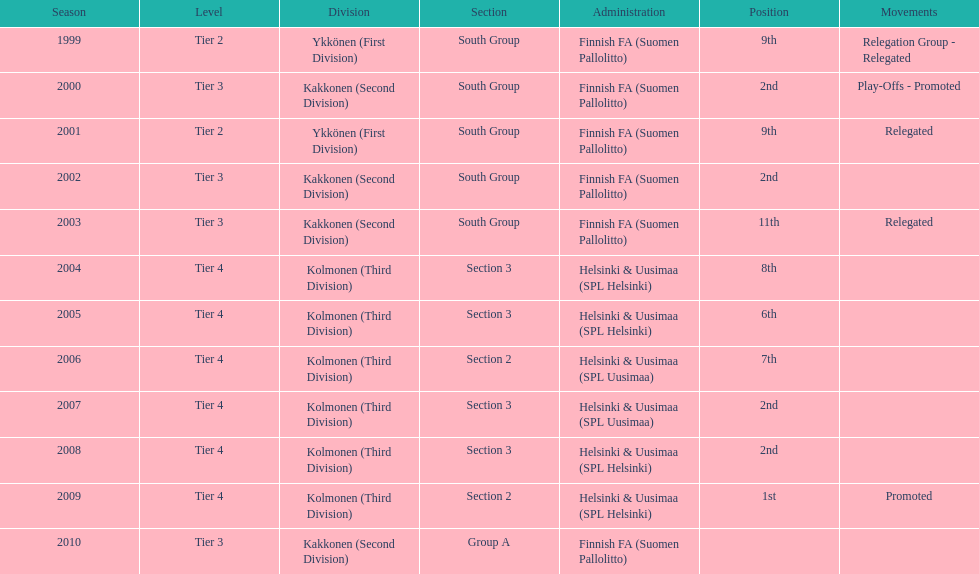Would you mind parsing the complete table? {'header': ['Season', 'Level', 'Division', 'Section', 'Administration', 'Position', 'Movements'], 'rows': [['1999', 'Tier 2', 'Ykkönen (First Division)', 'South Group', 'Finnish FA (Suomen Pallolitto)', '9th', 'Relegation Group - Relegated'], ['2000', 'Tier 3', 'Kakkonen (Second Division)', 'South Group', 'Finnish FA (Suomen Pallolitto)', '2nd', 'Play-Offs - Promoted'], ['2001', 'Tier 2', 'Ykkönen (First Division)', 'South Group', 'Finnish FA (Suomen Pallolitto)', '9th', 'Relegated'], ['2002', 'Tier 3', 'Kakkonen (Second Division)', 'South Group', 'Finnish FA (Suomen Pallolitto)', '2nd', ''], ['2003', 'Tier 3', 'Kakkonen (Second Division)', 'South Group', 'Finnish FA (Suomen Pallolitto)', '11th', 'Relegated'], ['2004', 'Tier 4', 'Kolmonen (Third Division)', 'Section 3', 'Helsinki & Uusimaa (SPL Helsinki)', '8th', ''], ['2005', 'Tier 4', 'Kolmonen (Third Division)', 'Section 3', 'Helsinki & Uusimaa (SPL Helsinki)', '6th', ''], ['2006', 'Tier 4', 'Kolmonen (Third Division)', 'Section 2', 'Helsinki & Uusimaa (SPL Uusimaa)', '7th', ''], ['2007', 'Tier 4', 'Kolmonen (Third Division)', 'Section 3', 'Helsinki & Uusimaa (SPL Uusimaa)', '2nd', ''], ['2008', 'Tier 4', 'Kolmonen (Third Division)', 'Section 3', 'Helsinki & Uusimaa (SPL Helsinki)', '2nd', ''], ['2009', 'Tier 4', 'Kolmonen (Third Division)', 'Section 2', 'Helsinki & Uusimaa (SPL Helsinki)', '1st', 'Promoted'], ['2010', 'Tier 3', 'Kakkonen (Second Division)', 'Group A', 'Finnish FA (Suomen Pallolitto)', '', '']]} How many stages had more than one relegated motion? 1. 